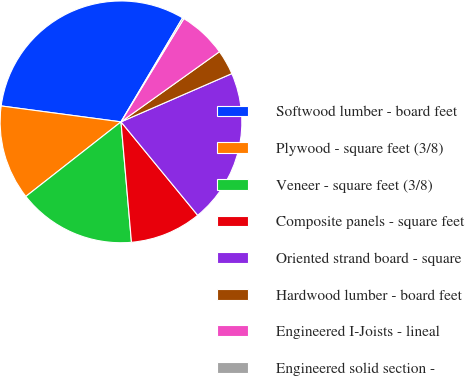Convert chart. <chart><loc_0><loc_0><loc_500><loc_500><pie_chart><fcel>Softwood lumber - board feet<fcel>Plywood - square feet (3/8)<fcel>Veneer - square feet (3/8)<fcel>Composite panels - square feet<fcel>Oriented strand board - square<fcel>Hardwood lumber - board feet<fcel>Engineered I-Joists - lineal<fcel>Engineered solid section -<nl><fcel>31.4%<fcel>12.68%<fcel>15.8%<fcel>9.56%<fcel>20.59%<fcel>3.32%<fcel>6.44%<fcel>0.2%<nl></chart> 